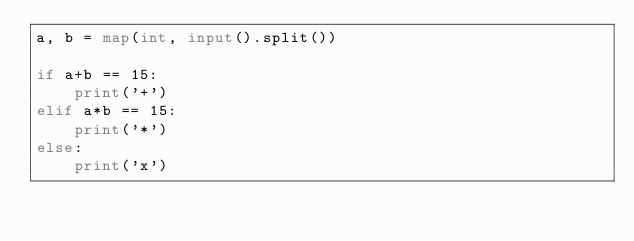<code> <loc_0><loc_0><loc_500><loc_500><_Python_>a, b = map(int, input().split())

if a+b == 15:
    print('+')
elif a*b == 15:
    print('*')
else:
    print('x')   </code> 